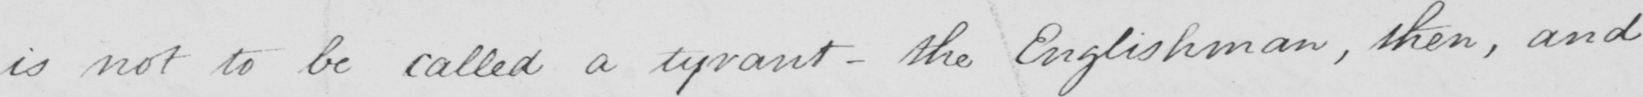What is written in this line of handwriting? is not to be called a tyrant  _  the Englishman , then , and 